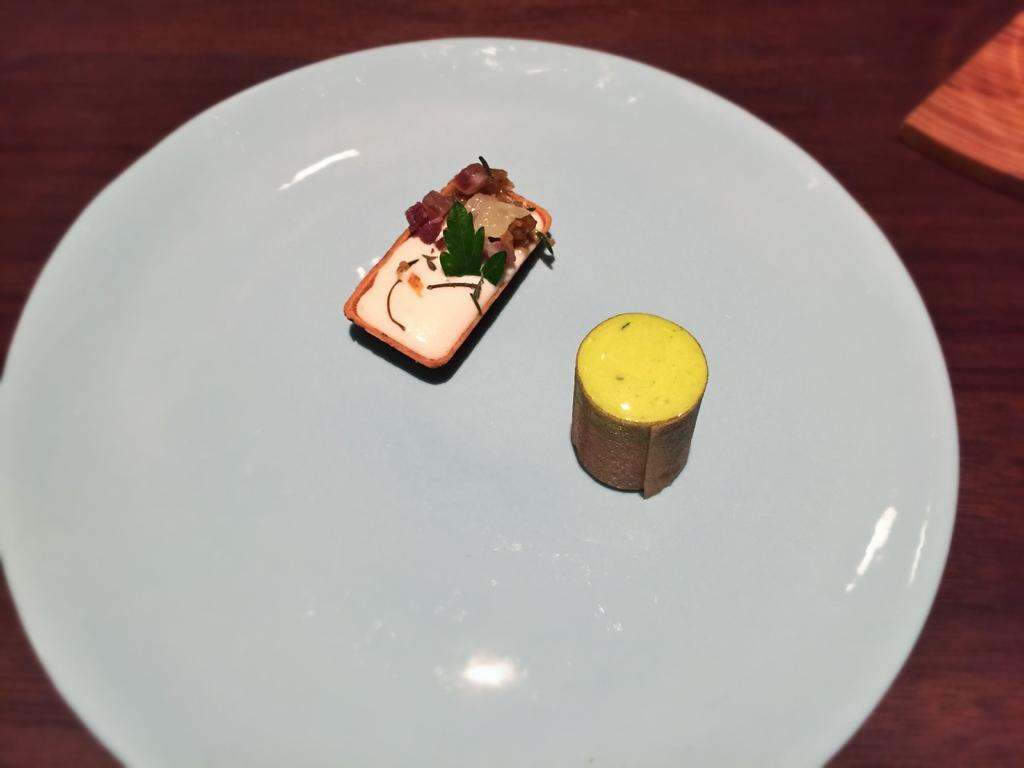What is on the plate in the image? There are objects on a plate in the image, which might contain food. What is the location of the plate in the image? The plate is on a table at the bottom of the image. What can be seen at the top right of the image? There is an object at the top right of the image. Can you describe the flight of the cat in the image? There is no cat present in the image, so it is not possible to describe its flight. 